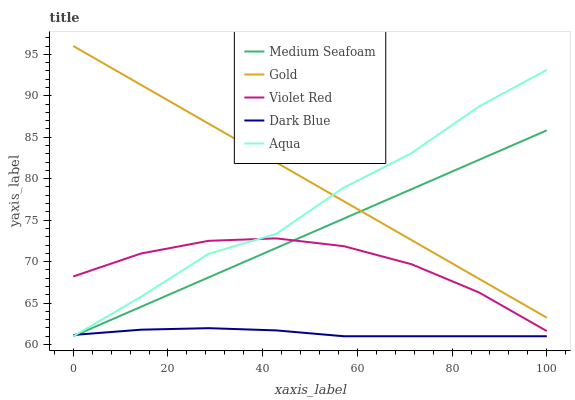Does Violet Red have the minimum area under the curve?
Answer yes or no. No. Does Violet Red have the maximum area under the curve?
Answer yes or no. No. Is Violet Red the smoothest?
Answer yes or no. No. Is Violet Red the roughest?
Answer yes or no. No. Does Violet Red have the lowest value?
Answer yes or no. No. Does Violet Red have the highest value?
Answer yes or no. No. Is Dark Blue less than Gold?
Answer yes or no. Yes. Is Violet Red greater than Dark Blue?
Answer yes or no. Yes. Does Dark Blue intersect Gold?
Answer yes or no. No. 